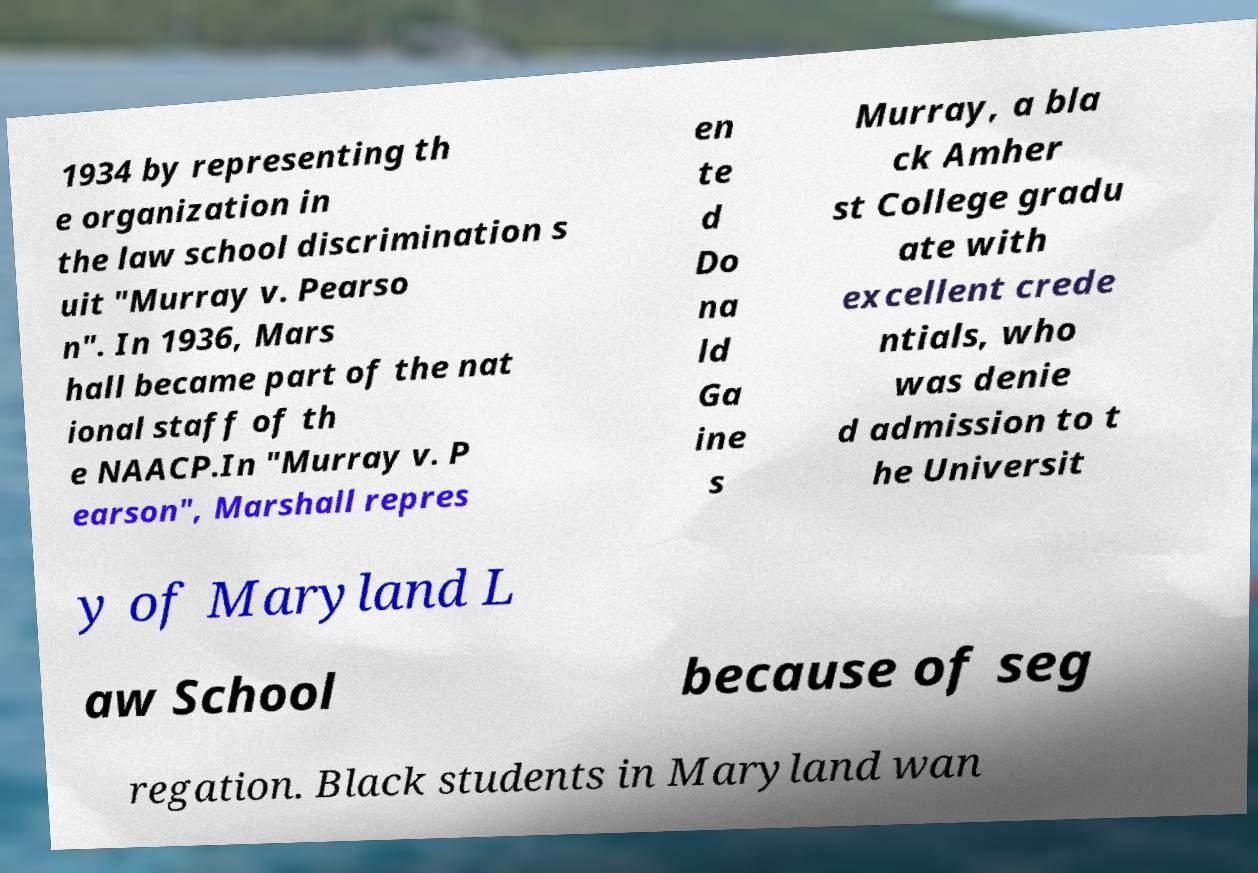Can you accurately transcribe the text from the provided image for me? 1934 by representing th e organization in the law school discrimination s uit "Murray v. Pearso n". In 1936, Mars hall became part of the nat ional staff of th e NAACP.In "Murray v. P earson", Marshall repres en te d Do na ld Ga ine s Murray, a bla ck Amher st College gradu ate with excellent crede ntials, who was denie d admission to t he Universit y of Maryland L aw School because of seg regation. Black students in Maryland wan 